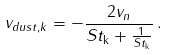Convert formula to latex. <formula><loc_0><loc_0><loc_500><loc_500>v _ { d u s t , k } = - \frac { 2 v _ { n } } { S t _ { \mathrm { k } } + \frac { 1 } { S t _ { \mathrm { k } } } } \, .</formula> 